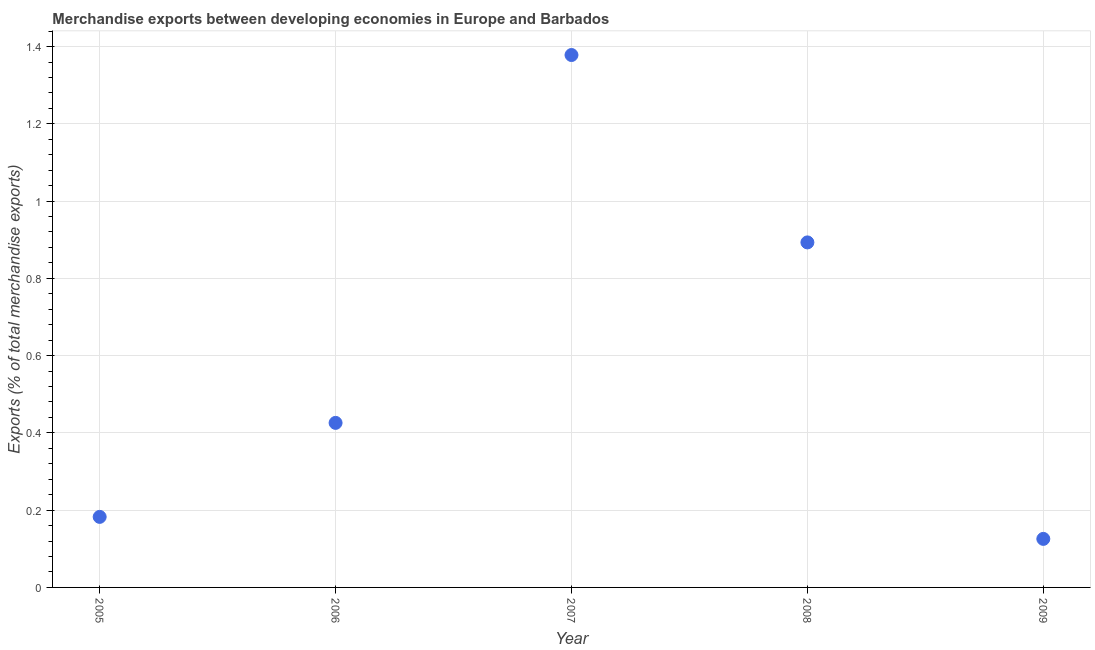What is the merchandise exports in 2005?
Ensure brevity in your answer.  0.18. Across all years, what is the maximum merchandise exports?
Provide a short and direct response. 1.38. Across all years, what is the minimum merchandise exports?
Offer a terse response. 0.13. In which year was the merchandise exports maximum?
Offer a very short reply. 2007. What is the sum of the merchandise exports?
Offer a terse response. 3.01. What is the difference between the merchandise exports in 2006 and 2008?
Provide a short and direct response. -0.47. What is the average merchandise exports per year?
Your answer should be compact. 0.6. What is the median merchandise exports?
Keep it short and to the point. 0.43. Do a majority of the years between 2005 and 2007 (inclusive) have merchandise exports greater than 1.4000000000000001 %?
Keep it short and to the point. No. What is the ratio of the merchandise exports in 2006 to that in 2008?
Your answer should be very brief. 0.48. Is the merchandise exports in 2008 less than that in 2009?
Provide a short and direct response. No. Is the difference between the merchandise exports in 2006 and 2007 greater than the difference between any two years?
Provide a short and direct response. No. What is the difference between the highest and the second highest merchandise exports?
Your answer should be very brief. 0.49. Is the sum of the merchandise exports in 2005 and 2008 greater than the maximum merchandise exports across all years?
Ensure brevity in your answer.  No. What is the difference between the highest and the lowest merchandise exports?
Your response must be concise. 1.25. In how many years, is the merchandise exports greater than the average merchandise exports taken over all years?
Make the answer very short. 2. How many years are there in the graph?
Make the answer very short. 5. Are the values on the major ticks of Y-axis written in scientific E-notation?
Give a very brief answer. No. Does the graph contain any zero values?
Ensure brevity in your answer.  No. Does the graph contain grids?
Ensure brevity in your answer.  Yes. What is the title of the graph?
Provide a short and direct response. Merchandise exports between developing economies in Europe and Barbados. What is the label or title of the Y-axis?
Keep it short and to the point. Exports (% of total merchandise exports). What is the Exports (% of total merchandise exports) in 2005?
Your answer should be compact. 0.18. What is the Exports (% of total merchandise exports) in 2006?
Offer a terse response. 0.43. What is the Exports (% of total merchandise exports) in 2007?
Make the answer very short. 1.38. What is the Exports (% of total merchandise exports) in 2008?
Provide a succinct answer. 0.89. What is the Exports (% of total merchandise exports) in 2009?
Ensure brevity in your answer.  0.13. What is the difference between the Exports (% of total merchandise exports) in 2005 and 2006?
Make the answer very short. -0.24. What is the difference between the Exports (% of total merchandise exports) in 2005 and 2007?
Offer a terse response. -1.2. What is the difference between the Exports (% of total merchandise exports) in 2005 and 2008?
Give a very brief answer. -0.71. What is the difference between the Exports (% of total merchandise exports) in 2005 and 2009?
Your answer should be very brief. 0.06. What is the difference between the Exports (% of total merchandise exports) in 2006 and 2007?
Offer a terse response. -0.95. What is the difference between the Exports (% of total merchandise exports) in 2006 and 2008?
Your answer should be compact. -0.47. What is the difference between the Exports (% of total merchandise exports) in 2006 and 2009?
Provide a succinct answer. 0.3. What is the difference between the Exports (% of total merchandise exports) in 2007 and 2008?
Provide a succinct answer. 0.49. What is the difference between the Exports (% of total merchandise exports) in 2007 and 2009?
Ensure brevity in your answer.  1.25. What is the difference between the Exports (% of total merchandise exports) in 2008 and 2009?
Offer a terse response. 0.77. What is the ratio of the Exports (% of total merchandise exports) in 2005 to that in 2006?
Your response must be concise. 0.43. What is the ratio of the Exports (% of total merchandise exports) in 2005 to that in 2007?
Keep it short and to the point. 0.13. What is the ratio of the Exports (% of total merchandise exports) in 2005 to that in 2008?
Provide a short and direct response. 0.2. What is the ratio of the Exports (% of total merchandise exports) in 2005 to that in 2009?
Offer a terse response. 1.45. What is the ratio of the Exports (% of total merchandise exports) in 2006 to that in 2007?
Provide a short and direct response. 0.31. What is the ratio of the Exports (% of total merchandise exports) in 2006 to that in 2008?
Provide a succinct answer. 0.48. What is the ratio of the Exports (% of total merchandise exports) in 2006 to that in 2009?
Keep it short and to the point. 3.39. What is the ratio of the Exports (% of total merchandise exports) in 2007 to that in 2008?
Make the answer very short. 1.54. What is the ratio of the Exports (% of total merchandise exports) in 2007 to that in 2009?
Offer a terse response. 10.97. What is the ratio of the Exports (% of total merchandise exports) in 2008 to that in 2009?
Your answer should be compact. 7.11. 